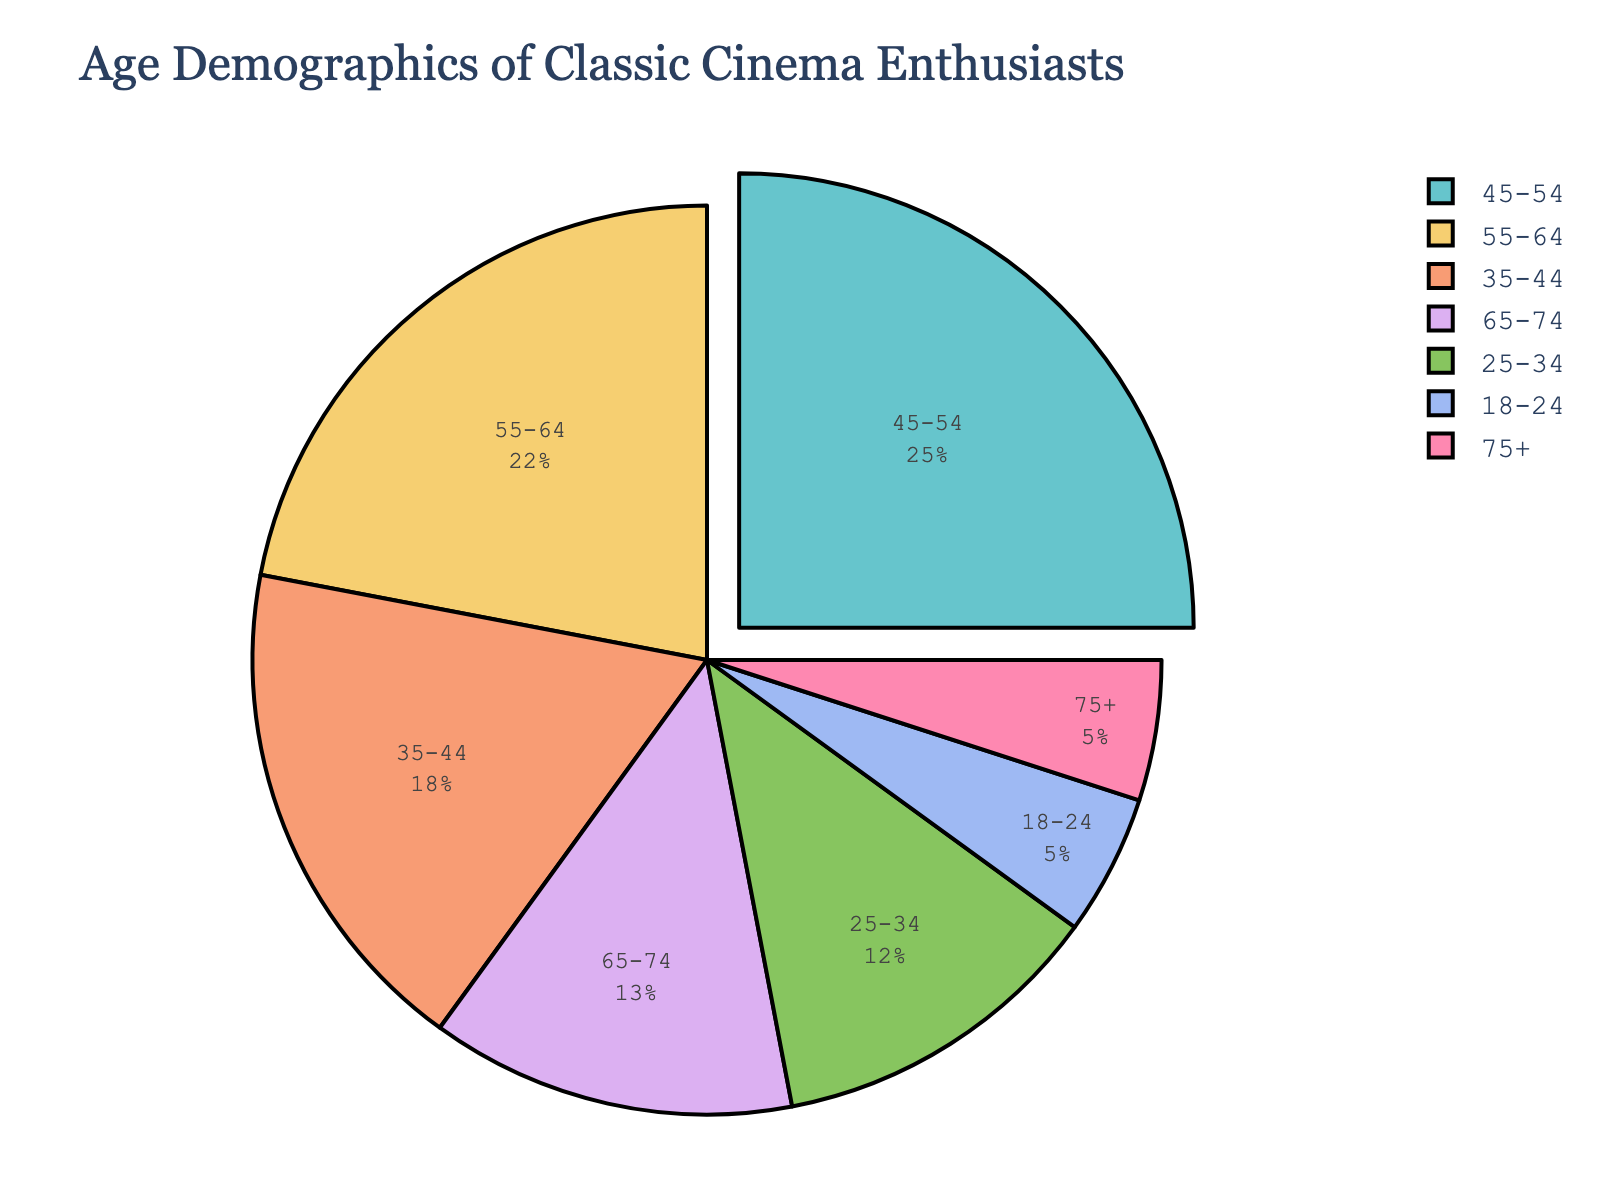What's the most represented age group among classic cinema enthusiasts? The age group with the highest percentage is the most represented. The figure shows the largest slice is for the age group 45-54.
Answer: 45-54 Which age group has a larger proportion of enthusiasts: 25-34 or 65-74? By comparing the sizes of the slices, the 25-34 age group (12%) has a larger proportion than the 65-74 age group (13%).
Answer: 65-74 What percentage of enthusiasts are aged 55 and above? Sum the percentages of the 55-64 (22%), 65-74 (13%), and 75+ (5%) age groups. 22 + 13 + 5 = 40%.
Answer: 40% Is the proportion of enthusiasts aged 35-44 greater than that of those aged 55-64? Compare the two percentages: 35-44 is 18%, and 55-64 is 22%. Since 18% is less than 22%, the proportion is not greater.
Answer: No What is the combined percentage for the age groups below 35 years? Add the percentages of the 18-24 (5%) and 25-34 (12%) age groups. 5 + 12 = 17%.
Answer: 17% Which age group has the smallest slice in the pie chart? The pie slice with the smallest percentage represents the smallest age group. Both 18-24 and 75+ have slices of 5%.
Answer: 18-24 and 75+ How many more percentage points are there in the age group 45-54 compared to 35-44? Subtract the percentage of the 35-44 age group from the percentage of the 45-54 age group. 25 - 18 = 7%.
Answer: 7 If enthusiasts below 25 years increased their proportion by 2%, how would this affect the 18-24 age group's percentage? The current percentage of the 18-24 age group is 5%. If it increased by 2%, it would become 5 + 2 = 7%.
Answer: 7% Are there more enthusiasts in the 65-74 age group than in the 18-24 and 75+ age groups combined? Add the percentages of the 18-24 (5%) and 75+ (5%) age groups, then compare it to 65-74. 5 + 5 = 10%, which is less than 13%.
Answer: Yes 